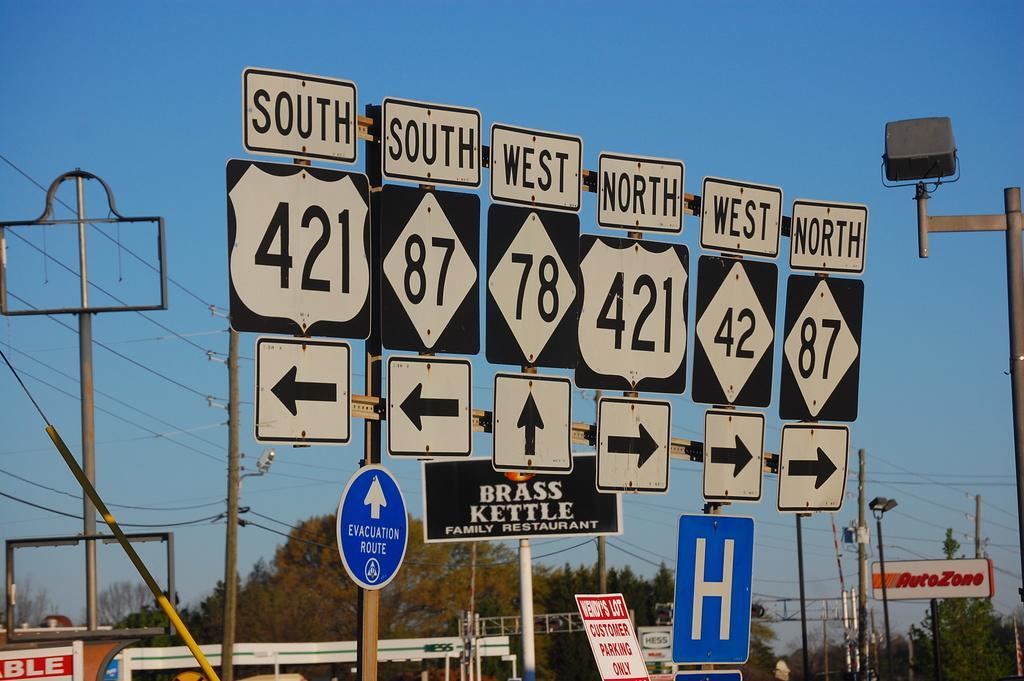<image>
Give a short and clear explanation of the subsequent image. A group of many highway signs tell drivers how to get to 421 and 87, among others. 